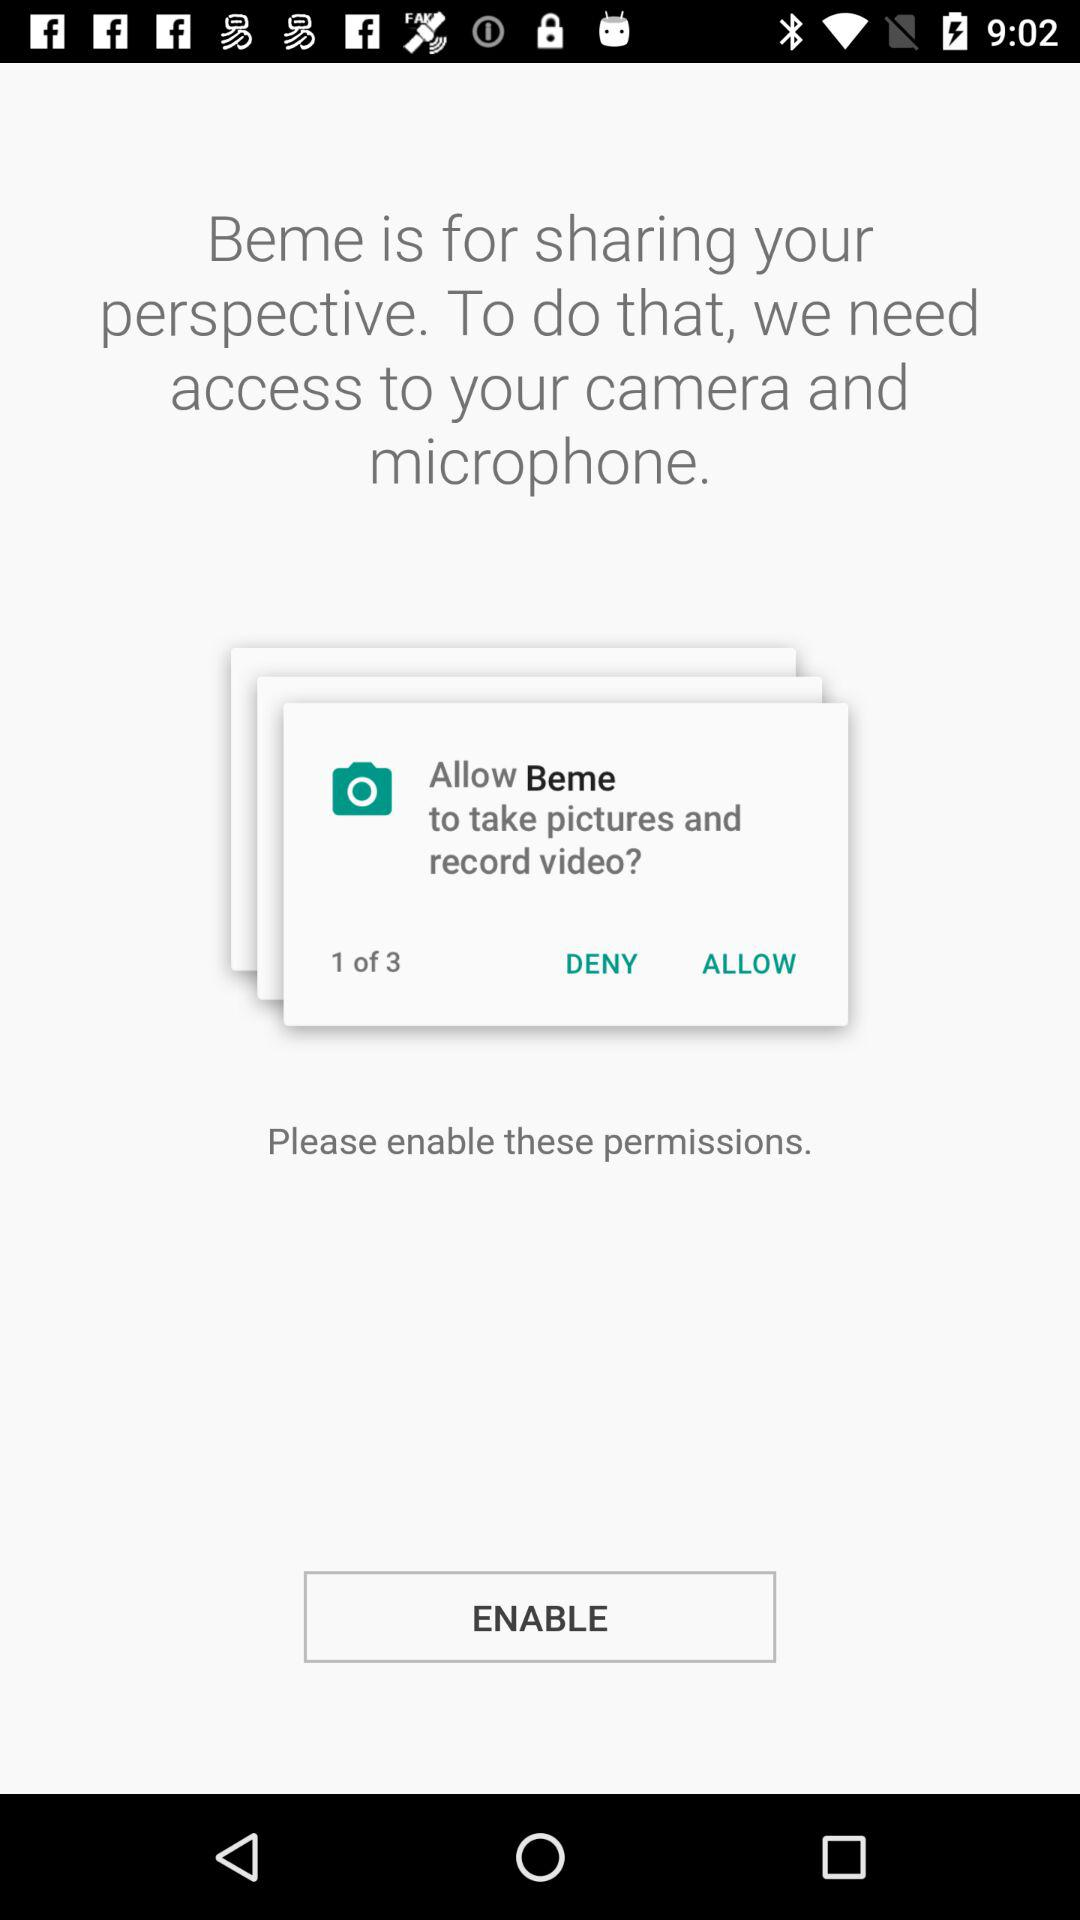What is the total count of the permissions? The total count of the permissions is 3. 